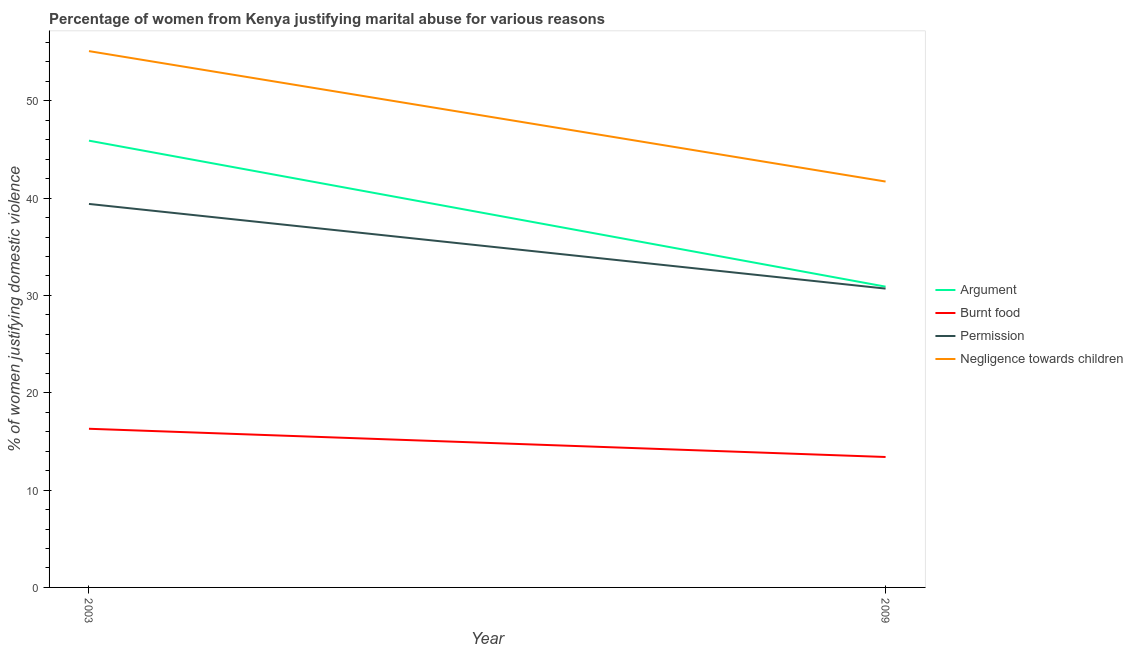Does the line corresponding to percentage of women justifying abuse in the case of an argument intersect with the line corresponding to percentage of women justifying abuse for burning food?
Provide a succinct answer. No. Is the number of lines equal to the number of legend labels?
Your answer should be very brief. Yes. What is the percentage of women justifying abuse in the case of an argument in 2003?
Your answer should be very brief. 45.9. Across all years, what is the maximum percentage of women justifying abuse for showing negligence towards children?
Offer a very short reply. 55.1. Across all years, what is the minimum percentage of women justifying abuse for going without permission?
Provide a succinct answer. 30.7. What is the total percentage of women justifying abuse for going without permission in the graph?
Provide a short and direct response. 70.1. What is the difference between the percentage of women justifying abuse for showing negligence towards children in 2009 and the percentage of women justifying abuse for going without permission in 2003?
Your answer should be very brief. 2.3. What is the average percentage of women justifying abuse for showing negligence towards children per year?
Offer a terse response. 48.4. In the year 2003, what is the difference between the percentage of women justifying abuse for showing negligence towards children and percentage of women justifying abuse in the case of an argument?
Ensure brevity in your answer.  9.2. What is the ratio of the percentage of women justifying abuse for going without permission in 2003 to that in 2009?
Keep it short and to the point. 1.28. Is the percentage of women justifying abuse for burning food in 2003 less than that in 2009?
Give a very brief answer. No. In how many years, is the percentage of women justifying abuse for burning food greater than the average percentage of women justifying abuse for burning food taken over all years?
Keep it short and to the point. 1. Is it the case that in every year, the sum of the percentage of women justifying abuse in the case of an argument and percentage of women justifying abuse for showing negligence towards children is greater than the sum of percentage of women justifying abuse for burning food and percentage of women justifying abuse for going without permission?
Your response must be concise. Yes. Is it the case that in every year, the sum of the percentage of women justifying abuse in the case of an argument and percentage of women justifying abuse for burning food is greater than the percentage of women justifying abuse for going without permission?
Make the answer very short. Yes. Is the percentage of women justifying abuse for burning food strictly greater than the percentage of women justifying abuse in the case of an argument over the years?
Your answer should be compact. No. Is the percentage of women justifying abuse for burning food strictly less than the percentage of women justifying abuse in the case of an argument over the years?
Provide a succinct answer. Yes. Are the values on the major ticks of Y-axis written in scientific E-notation?
Your response must be concise. No. Does the graph contain any zero values?
Your answer should be very brief. No. Where does the legend appear in the graph?
Your answer should be compact. Center right. How are the legend labels stacked?
Provide a short and direct response. Vertical. What is the title of the graph?
Keep it short and to the point. Percentage of women from Kenya justifying marital abuse for various reasons. Does "Social equity" appear as one of the legend labels in the graph?
Make the answer very short. No. What is the label or title of the X-axis?
Ensure brevity in your answer.  Year. What is the label or title of the Y-axis?
Your answer should be very brief. % of women justifying domestic violence. What is the % of women justifying domestic violence of Argument in 2003?
Keep it short and to the point. 45.9. What is the % of women justifying domestic violence in Burnt food in 2003?
Your answer should be compact. 16.3. What is the % of women justifying domestic violence of Permission in 2003?
Your response must be concise. 39.4. What is the % of women justifying domestic violence in Negligence towards children in 2003?
Offer a terse response. 55.1. What is the % of women justifying domestic violence in Argument in 2009?
Offer a terse response. 30.9. What is the % of women justifying domestic violence of Permission in 2009?
Ensure brevity in your answer.  30.7. What is the % of women justifying domestic violence in Negligence towards children in 2009?
Offer a terse response. 41.7. Across all years, what is the maximum % of women justifying domestic violence of Argument?
Give a very brief answer. 45.9. Across all years, what is the maximum % of women justifying domestic violence of Burnt food?
Your answer should be compact. 16.3. Across all years, what is the maximum % of women justifying domestic violence of Permission?
Your answer should be very brief. 39.4. Across all years, what is the maximum % of women justifying domestic violence in Negligence towards children?
Your answer should be very brief. 55.1. Across all years, what is the minimum % of women justifying domestic violence in Argument?
Provide a succinct answer. 30.9. Across all years, what is the minimum % of women justifying domestic violence in Burnt food?
Keep it short and to the point. 13.4. Across all years, what is the minimum % of women justifying domestic violence of Permission?
Your answer should be very brief. 30.7. Across all years, what is the minimum % of women justifying domestic violence of Negligence towards children?
Provide a succinct answer. 41.7. What is the total % of women justifying domestic violence in Argument in the graph?
Your answer should be very brief. 76.8. What is the total % of women justifying domestic violence of Burnt food in the graph?
Ensure brevity in your answer.  29.7. What is the total % of women justifying domestic violence in Permission in the graph?
Provide a short and direct response. 70.1. What is the total % of women justifying domestic violence in Negligence towards children in the graph?
Your answer should be compact. 96.8. What is the difference between the % of women justifying domestic violence of Burnt food in 2003 and that in 2009?
Provide a short and direct response. 2.9. What is the difference between the % of women justifying domestic violence in Negligence towards children in 2003 and that in 2009?
Keep it short and to the point. 13.4. What is the difference between the % of women justifying domestic violence in Argument in 2003 and the % of women justifying domestic violence in Burnt food in 2009?
Give a very brief answer. 32.5. What is the difference between the % of women justifying domestic violence in Argument in 2003 and the % of women justifying domestic violence in Permission in 2009?
Your answer should be compact. 15.2. What is the difference between the % of women justifying domestic violence in Burnt food in 2003 and the % of women justifying domestic violence in Permission in 2009?
Make the answer very short. -14.4. What is the difference between the % of women justifying domestic violence of Burnt food in 2003 and the % of women justifying domestic violence of Negligence towards children in 2009?
Your answer should be very brief. -25.4. What is the difference between the % of women justifying domestic violence of Permission in 2003 and the % of women justifying domestic violence of Negligence towards children in 2009?
Offer a terse response. -2.3. What is the average % of women justifying domestic violence of Argument per year?
Provide a short and direct response. 38.4. What is the average % of women justifying domestic violence in Burnt food per year?
Make the answer very short. 14.85. What is the average % of women justifying domestic violence of Permission per year?
Ensure brevity in your answer.  35.05. What is the average % of women justifying domestic violence of Negligence towards children per year?
Your answer should be compact. 48.4. In the year 2003, what is the difference between the % of women justifying domestic violence of Argument and % of women justifying domestic violence of Burnt food?
Provide a short and direct response. 29.6. In the year 2003, what is the difference between the % of women justifying domestic violence in Argument and % of women justifying domestic violence in Permission?
Your answer should be compact. 6.5. In the year 2003, what is the difference between the % of women justifying domestic violence in Argument and % of women justifying domestic violence in Negligence towards children?
Ensure brevity in your answer.  -9.2. In the year 2003, what is the difference between the % of women justifying domestic violence in Burnt food and % of women justifying domestic violence in Permission?
Keep it short and to the point. -23.1. In the year 2003, what is the difference between the % of women justifying domestic violence in Burnt food and % of women justifying domestic violence in Negligence towards children?
Ensure brevity in your answer.  -38.8. In the year 2003, what is the difference between the % of women justifying domestic violence in Permission and % of women justifying domestic violence in Negligence towards children?
Offer a very short reply. -15.7. In the year 2009, what is the difference between the % of women justifying domestic violence of Burnt food and % of women justifying domestic violence of Permission?
Give a very brief answer. -17.3. In the year 2009, what is the difference between the % of women justifying domestic violence of Burnt food and % of women justifying domestic violence of Negligence towards children?
Your answer should be very brief. -28.3. What is the ratio of the % of women justifying domestic violence of Argument in 2003 to that in 2009?
Provide a short and direct response. 1.49. What is the ratio of the % of women justifying domestic violence in Burnt food in 2003 to that in 2009?
Make the answer very short. 1.22. What is the ratio of the % of women justifying domestic violence in Permission in 2003 to that in 2009?
Give a very brief answer. 1.28. What is the ratio of the % of women justifying domestic violence of Negligence towards children in 2003 to that in 2009?
Ensure brevity in your answer.  1.32. What is the difference between the highest and the second highest % of women justifying domestic violence of Burnt food?
Ensure brevity in your answer.  2.9. What is the difference between the highest and the lowest % of women justifying domestic violence of Burnt food?
Your answer should be compact. 2.9. What is the difference between the highest and the lowest % of women justifying domestic violence in Permission?
Offer a terse response. 8.7. What is the difference between the highest and the lowest % of women justifying domestic violence in Negligence towards children?
Your answer should be compact. 13.4. 